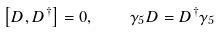Convert formula to latex. <formula><loc_0><loc_0><loc_500><loc_500>\left [ D , D ^ { \dagger } \right ] = 0 , \quad \gamma _ { 5 } D = D ^ { \dagger } \gamma _ { 5 }</formula> 